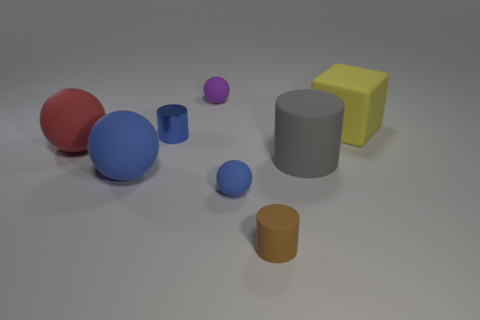How many rubber things are either balls or gray objects?
Offer a very short reply. 5. Is the number of large blue things that are behind the big cylinder greater than the number of yellow blocks in front of the yellow object?
Make the answer very short. No. What number of other objects are the same size as the red matte thing?
Provide a succinct answer. 3. What size is the rubber cylinder that is in front of the tiny sphere in front of the big yellow rubber block?
Offer a very short reply. Small. What number of large objects are purple objects or brown cylinders?
Your answer should be very brief. 0. There is a blue thing to the right of the small cylinder that is left of the tiny sphere in front of the big gray rubber cylinder; what size is it?
Ensure brevity in your answer.  Small. Is there anything else of the same color as the tiny shiny cylinder?
Give a very brief answer. Yes. There is a tiny cylinder to the left of the blue thing on the right side of the tiny sphere that is behind the tiny blue ball; what is it made of?
Ensure brevity in your answer.  Metal. Is the shape of the tiny purple object the same as the small brown matte thing?
Give a very brief answer. No. Is there any other thing that has the same material as the red sphere?
Keep it short and to the point. Yes. 